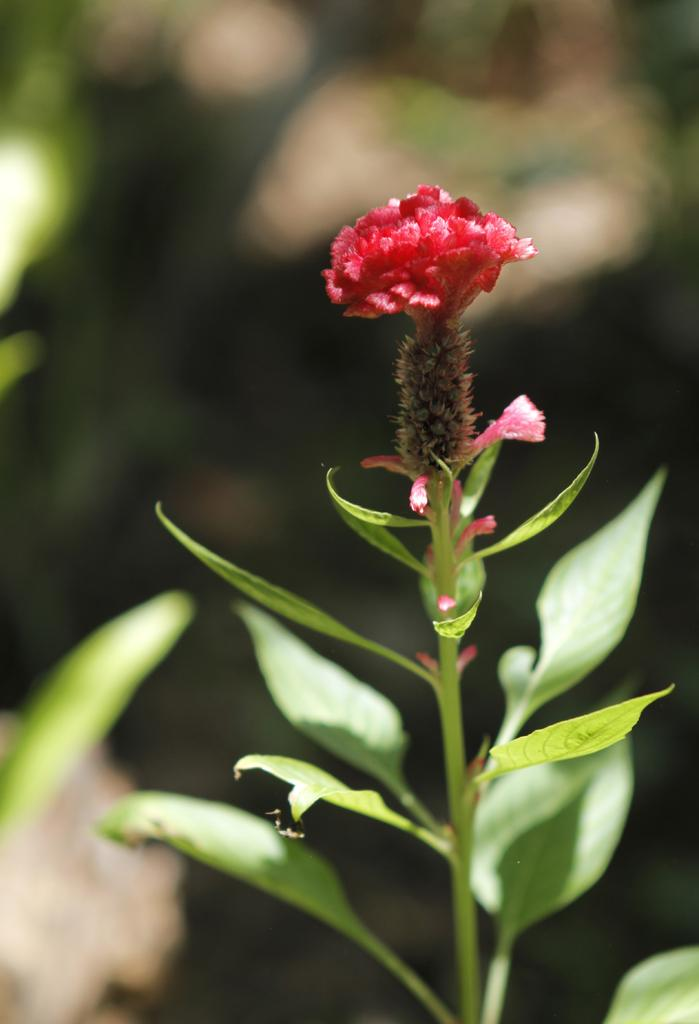What is the main subject of the image? There is a plant in the image. What features can be observed on the plant? The plant has leaves and a flower. Can you describe the background of the image? The background of the image is blurred. What type of powder is being used to respect the plant in the image? There is no powder or indication of respecting the plant in the image; it simply shows a plant with leaves and a flower. 